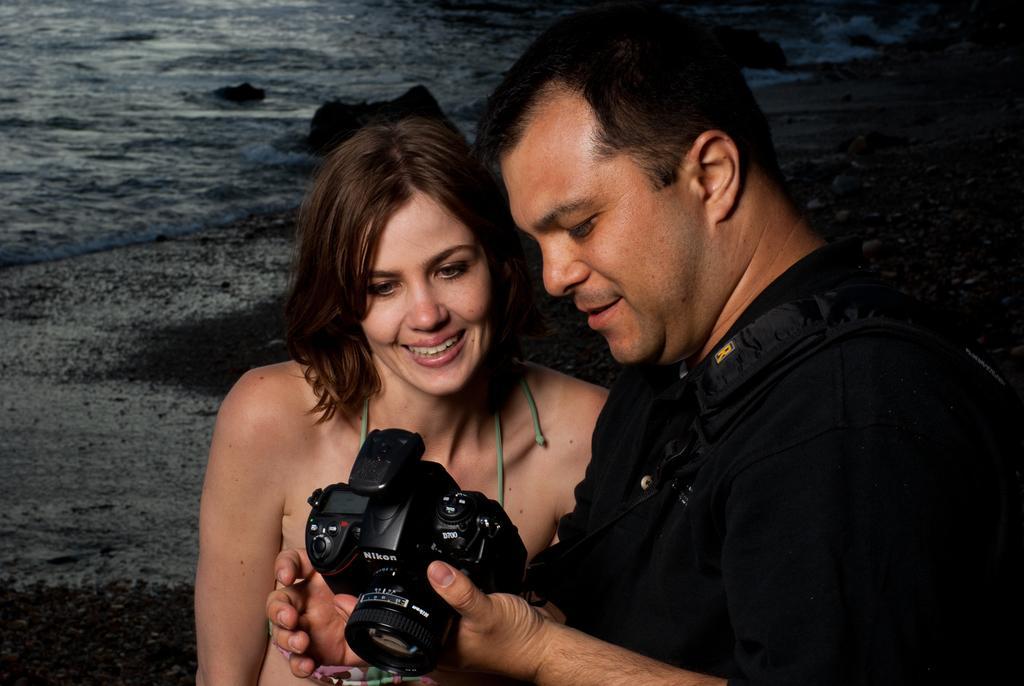Describe this image in one or two sentences. On the background we can see a beach. Here we can see a man standing and holding a camera in his hand. We can see a woman standing beside to him and smiling. They both are staring at the camera. 